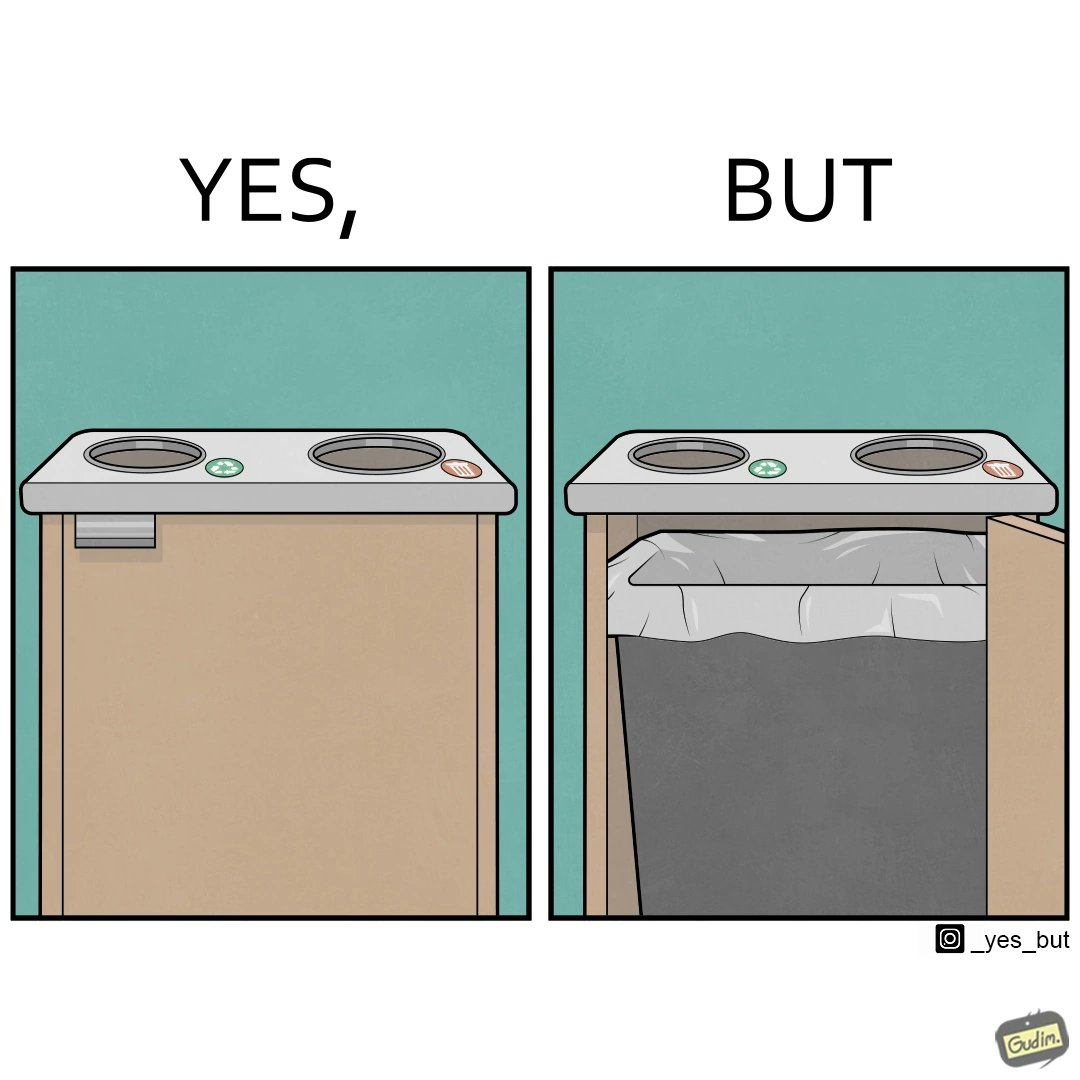What is shown in the left half versus the right half of this image? In the left part of the image: The image shows a garbage collection box with two holes. The hole with the green recycling sign next to it says indicates that all recyclable materials should be thrown into that hole. The hole with a red trash can lable next to it means that all other i.e non recyclable waste should be thrown into this hole. There also is a handle on the front of the box. In the right part of the image: The image shows that there is only one common bin below the holes. The hole with the green recycling sign next to it says indicates that all recyclable materials should be thrown into that hole. The hole with a red trash can lable next to it means that all other i.e non recyclable waste should be thrown into this hole. But since there is only one common bin collecti whatever is thrown through these holes, there is no separation. 